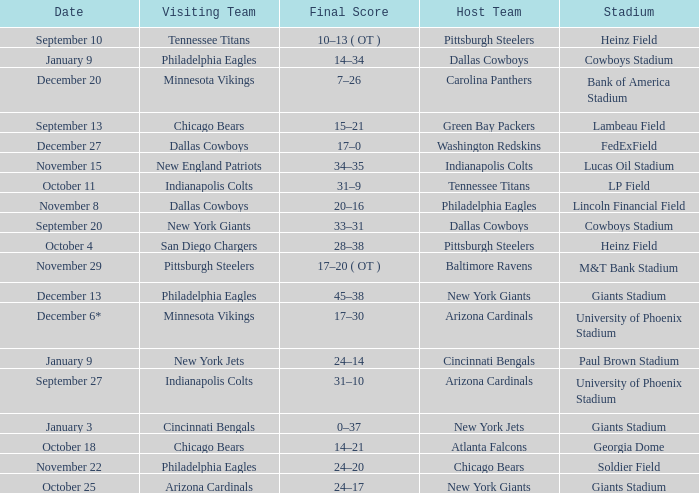Tell me the final score for january 9 for cincinnati bengals 24–14. 